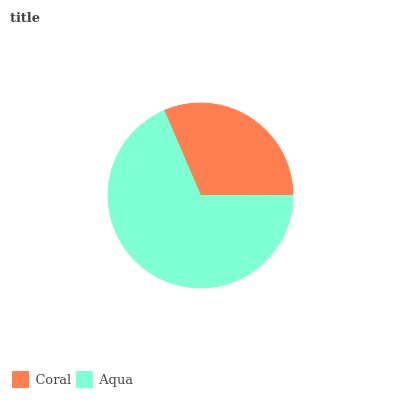Is Coral the minimum?
Answer yes or no. Yes. Is Aqua the maximum?
Answer yes or no. Yes. Is Aqua the minimum?
Answer yes or no. No. Is Aqua greater than Coral?
Answer yes or no. Yes. Is Coral less than Aqua?
Answer yes or no. Yes. Is Coral greater than Aqua?
Answer yes or no. No. Is Aqua less than Coral?
Answer yes or no. No. Is Aqua the high median?
Answer yes or no. Yes. Is Coral the low median?
Answer yes or no. Yes. Is Coral the high median?
Answer yes or no. No. Is Aqua the low median?
Answer yes or no. No. 